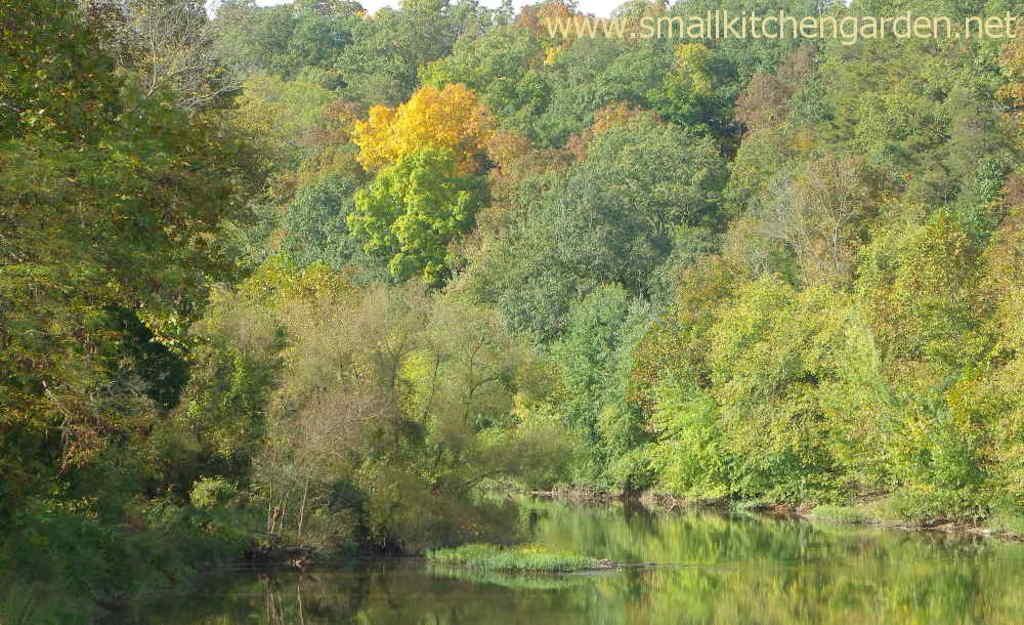Can you describe this image briefly? In this image we can see plants, trees, water and sky. 